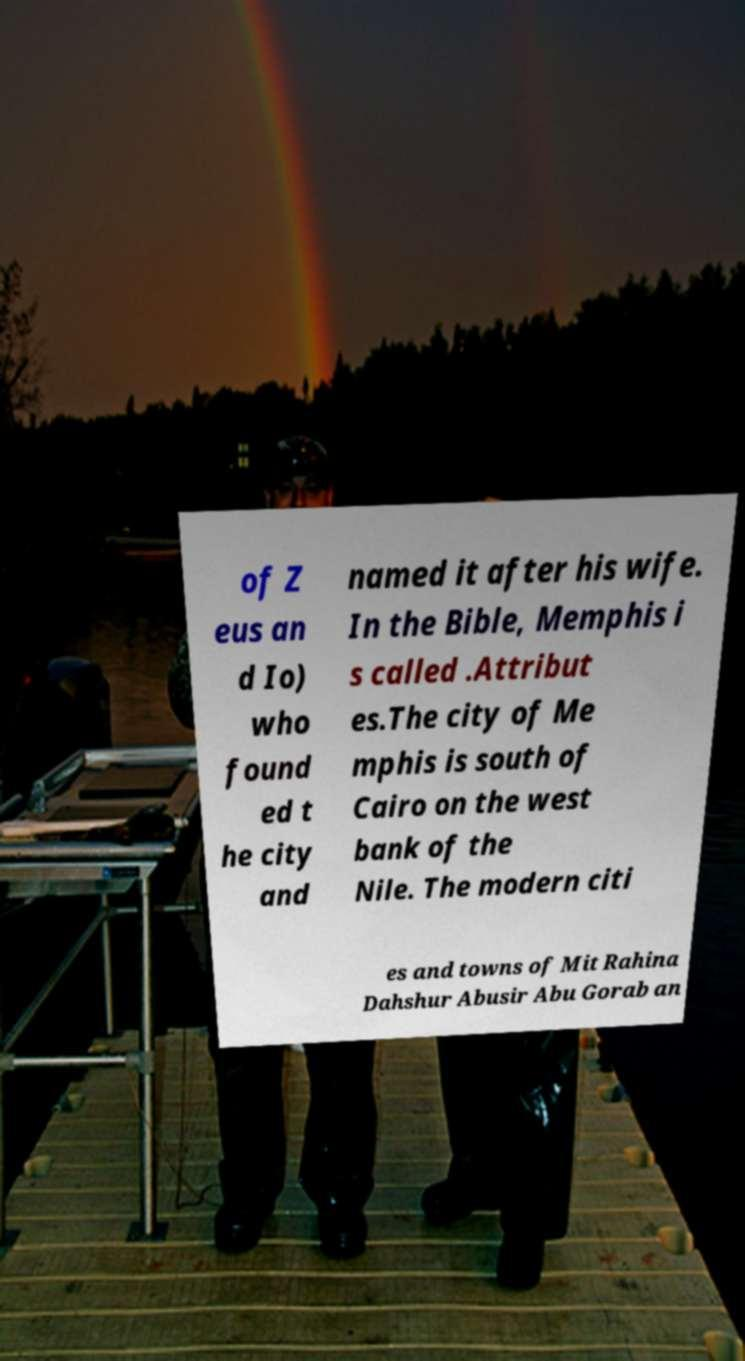Can you accurately transcribe the text from the provided image for me? of Z eus an d Io) who found ed t he city and named it after his wife. In the Bible, Memphis i s called .Attribut es.The city of Me mphis is south of Cairo on the west bank of the Nile. The modern citi es and towns of Mit Rahina Dahshur Abusir Abu Gorab an 